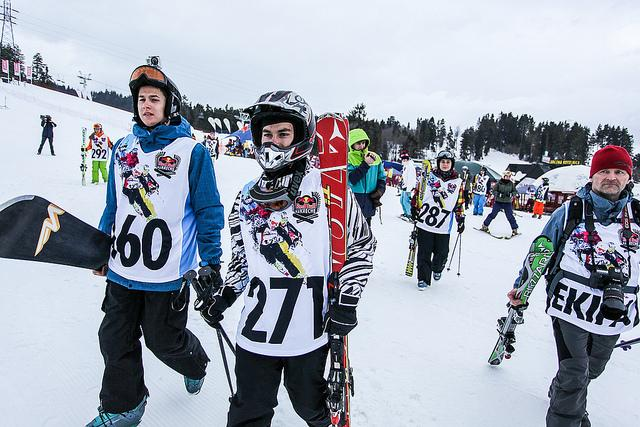WHat kind of competition is taking place? Please explain your reasoning. skiing. The people are all carrying snowboards. 